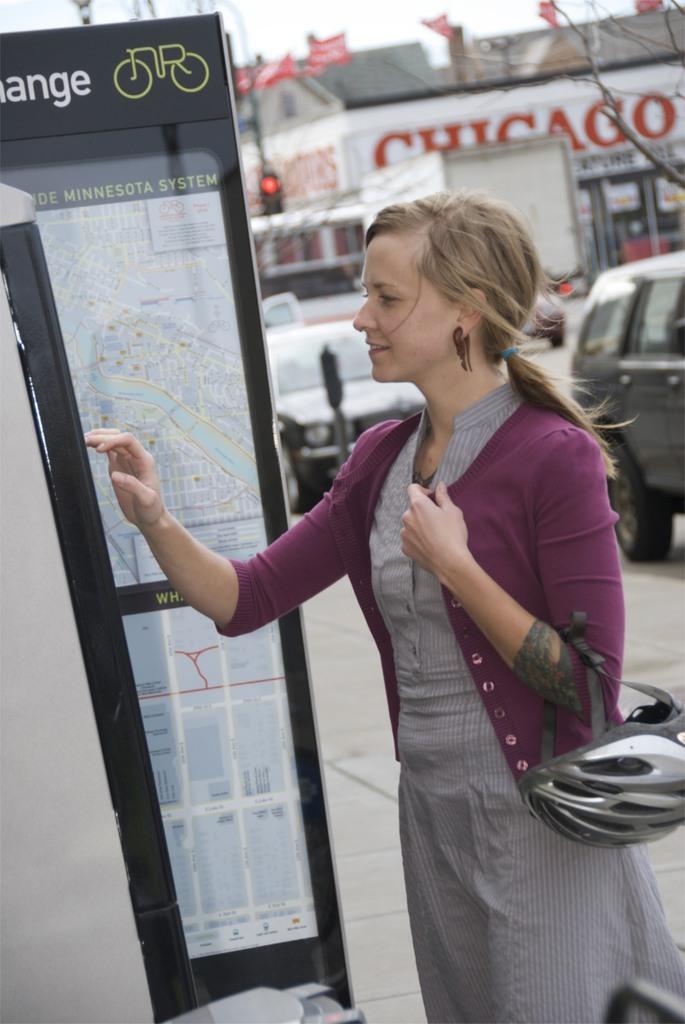Could you give a brief overview of what you see in this image? In this image there is a girl in the middle who is holding the helmet with one hand and looking at the map which is in front of her. In the background there are cars on the road. Behind them there is a traffic signal light. In the background there is a building on which there are flags. 